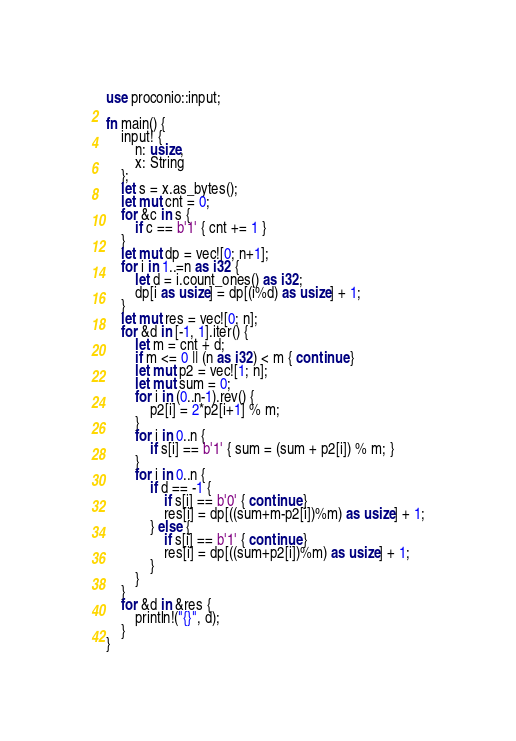<code> <loc_0><loc_0><loc_500><loc_500><_Rust_>use proconio::input;

fn main() {
    input! {
        n: usize,
        x: String
    };
    let s = x.as_bytes();
    let mut cnt = 0;
    for &c in s {
        if c == b'1' { cnt += 1 }
    }
    let mut dp = vec![0; n+1];
    for i in 1..=n as i32 {
        let d = i.count_ones() as i32;
        dp[i as usize] = dp[(i%d) as usize] + 1;
    }
    let mut res = vec![0; n];
    for &d in [-1, 1].iter() {
        let m = cnt + d;
        if m <= 0 || (n as i32) < m { continue }
        let mut p2 = vec![1; n];
        let mut sum = 0;
        for i in (0..n-1).rev() {
            p2[i] = 2*p2[i+1] % m;
        }
        for i in 0..n {
            if s[i] == b'1' { sum = (sum + p2[i]) % m; }
        }
        for i in 0..n {
            if d == -1 {
                if s[i] == b'0' { continue }
                res[i] = dp[((sum+m-p2[i])%m) as usize] + 1;
            } else {
                if s[i] == b'1' { continue }
                res[i] = dp[((sum+p2[i])%m) as usize] + 1;
            }
        }
    }
    for &d in &res {
        println!("{}", d);
    }
}
</code> 